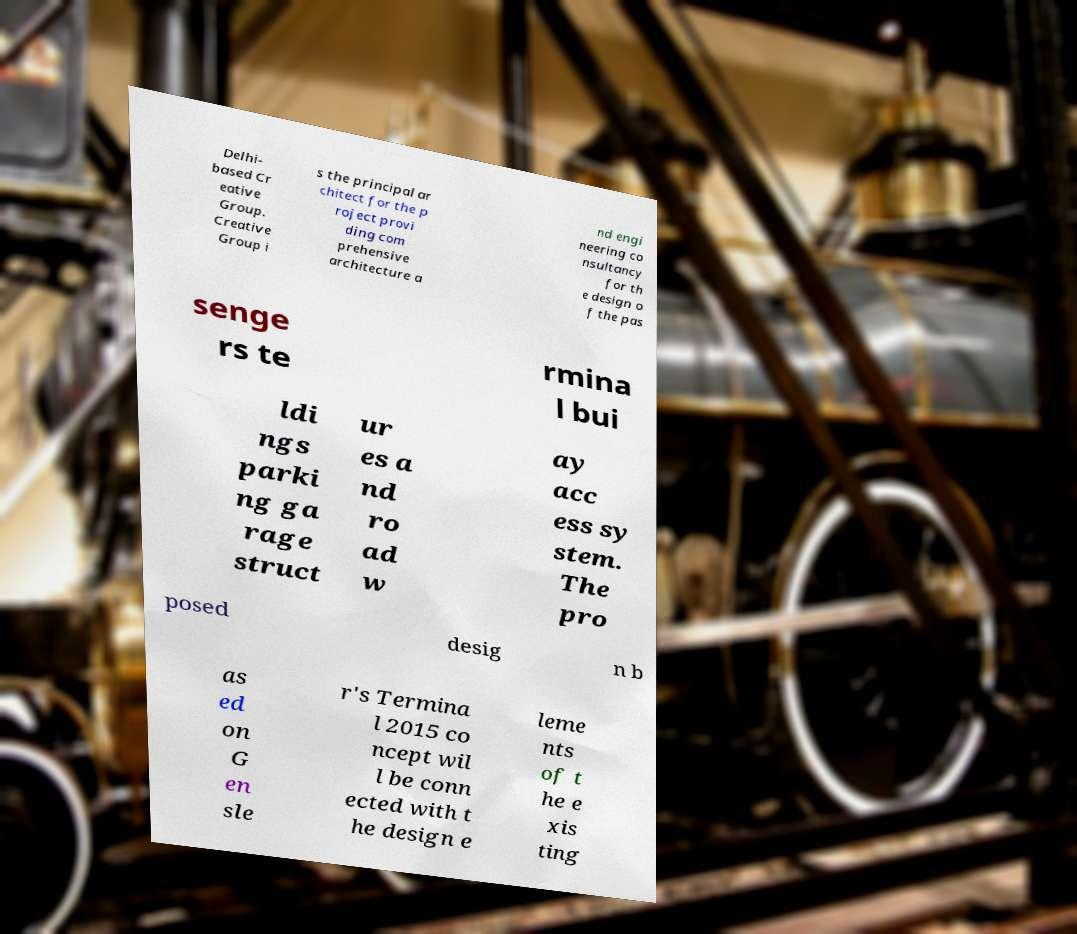Please read and relay the text visible in this image. What does it say? Delhi- based Cr eative Group. Creative Group i s the principal ar chitect for the p roject provi ding com prehensive architecture a nd engi neering co nsultancy for th e design o f the pas senge rs te rmina l bui ldi ngs parki ng ga rage struct ur es a nd ro ad w ay acc ess sy stem. The pro posed desig n b as ed on G en sle r's Termina l 2015 co ncept wil l be conn ected with t he design e leme nts of t he e xis ting 